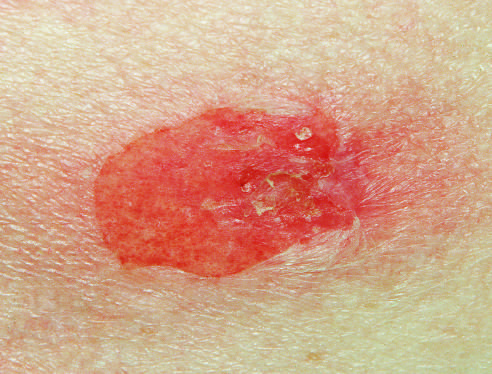what is seen in pemphigus vulgaris?
Answer the question using a single word or phrase. A typical blister 